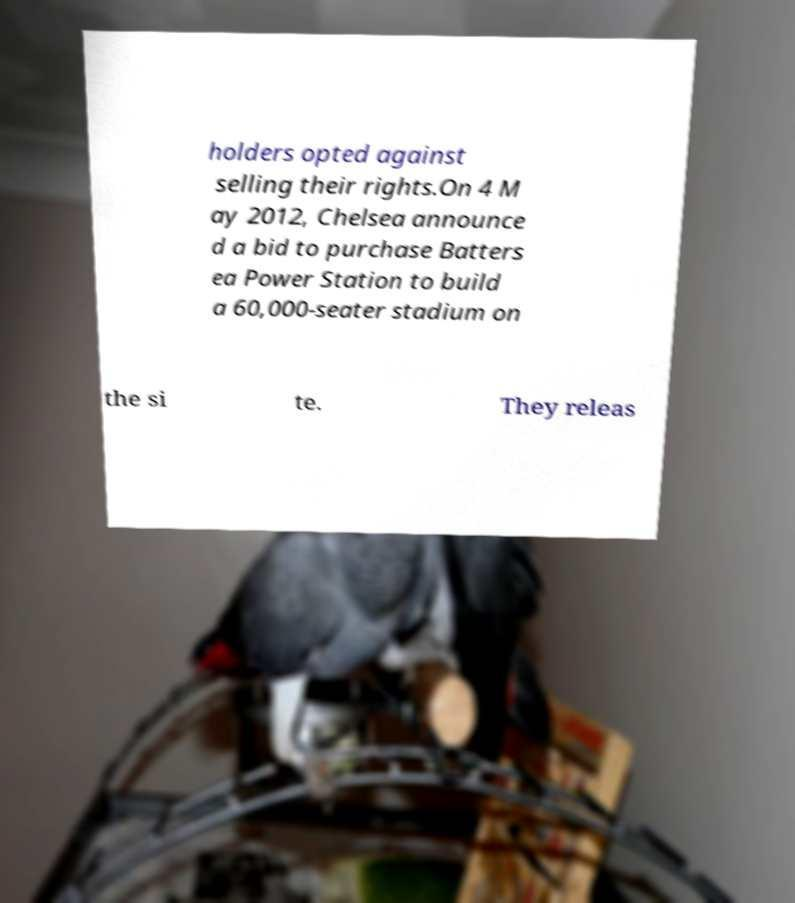Could you assist in decoding the text presented in this image and type it out clearly? holders opted against selling their rights.On 4 M ay 2012, Chelsea announce d a bid to purchase Batters ea Power Station to build a 60,000-seater stadium on the si te. They releas 